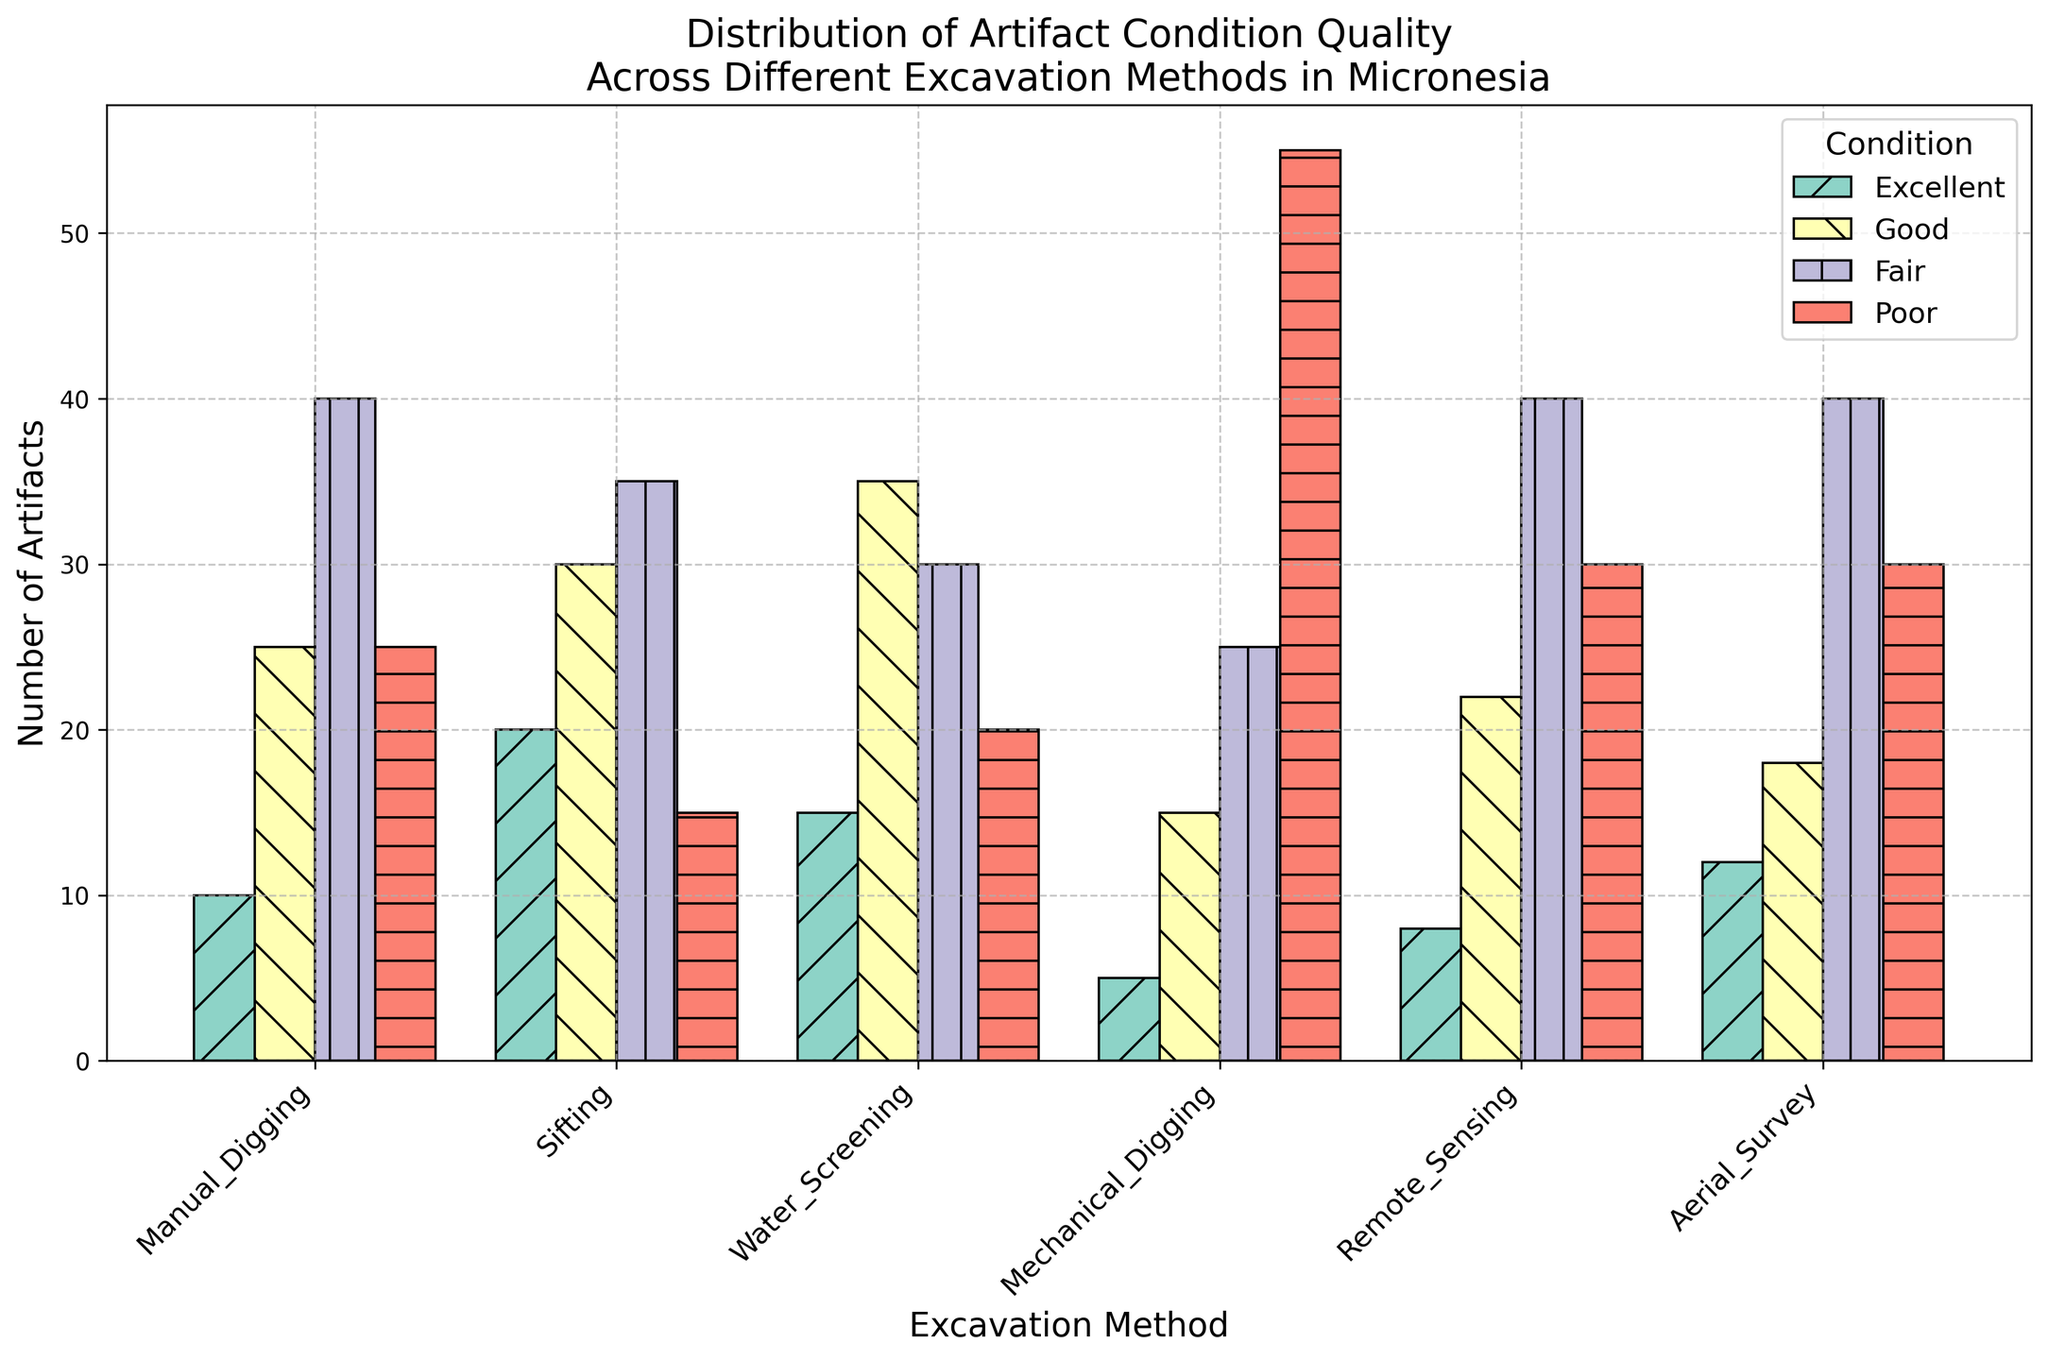What excavation method uncovers the most artifacts in excellent condition? To determine which excavation method uncovers the most artifacts in excellent condition, look at the height of the blue bars representing the 'Excellent' category. The tallest blue bar corresponds to the 'Sifting' method with a height indicating 20 artifacts.
Answer: Sifting Which excavation method finds the most artifacts in poor condition? To find the excavation method that uncovers the most artifacts in poor condition, examine the heights of the green bars representing the 'Poor' category. The highest green bar corresponds to 'Mechanical Digging' with a height indicating 55 artifacts.
Answer: Mechanical Digging Compare the number of excellent artifacts found by Water Screening and Aerial Survey. Which method uncovers more? Look at the heights of the blue bars for both 'Water Screening' and 'Aerial Survey'. The 'Water Screening' method has a bar reaching a height of 15 artifacts, while the 'Aerial Survey' method's bar reaches 12 artifacts. Thus, 'Water Screening' uncovers more excellent artifacts.
Answer: Water Screening What is the average number of fair artifacts found across all excavation methods? To find the average number of fair artifacts, add the number of fair artifacts found by each method: 40 (Manual Digging) + 35 (Sifting) + 30 (Water Screening) + 25 (Mechanical Digging) + 40 (Remote Sensing) + 40 (Aerial Survey) = 210. Then divide by the number of methods (6): 210 / 6 = 35.
Answer: 35 Which excavation method has the smallest proportion of good artifacts among all its findings? To find the method with the smallest proportion of good artifacts, compare the heights of the orange bars relative to the total height (sum of all bars) for each method. 'Mechanical Digging' has a small orange bar (15 artifacts) compared to a high total (100 artifacts), making it the method with the smallest proportion of good artifacts.
Answer: Mechanical Digging How many more poor artifacts are found by Mechanical Digging compared to Water Screening? To find this, subtract the number of poor artifacts found by Water Screening (20) from the number found by Mechanical Digging (55): 55 - 20 = 35.
Answer: 35 Which category of artifact condition has the greatest number in total across all methods? Sum the number of artifacts in each condition category across all methods. 
- Excellent: 10 + 20 + 15 + 5 + 8 + 12 = 70
- Good: 25 + 30 + 35 + 15 + 22 + 18 = 145
- Fair: 40 + 35 + 30 + 25 + 40 + 40 = 210
- Poor: 25 + 15 + 20 + 55 + 30 + 30 = 175 
The 'Fair' category has the greatest total number.
Answer: Fair Is the distribution of artifact condition quality found by Remote Sensing more even compared to Mechanical Digging? To assess evenness, compare the relative heights of bars in each category for 'Remote Sensing' and 'Mechanical Digging'. 'Remote Sensing' has bars of relatively similar heights (8, 22, 40, 30), while 'Mechanical Digging' has a very tall green bar (55) compared to the others (5, 15, 25). Therefore, 'Remote Sensing' has a more even distribution.
Answer: Yes What is the total number of artifacts found by Sifting? Sum the number of artifacts in each condition category for 'Sifting': 20 (Excellent) + 30 (Good) + 35 (Fair) + 15 (Poor) = 100.
Answer: 100 Which excavation methods uncover the same number of fair artifacts? Identify the heights of the purple bars for the 'Fair' category. Both 'Manual Digging' and 'Aerial Survey' have purple bars representing 40 artifacts, indicating they uncover the same number of fair artifacts.
Answer: Manual Digging and Aerial Survey 